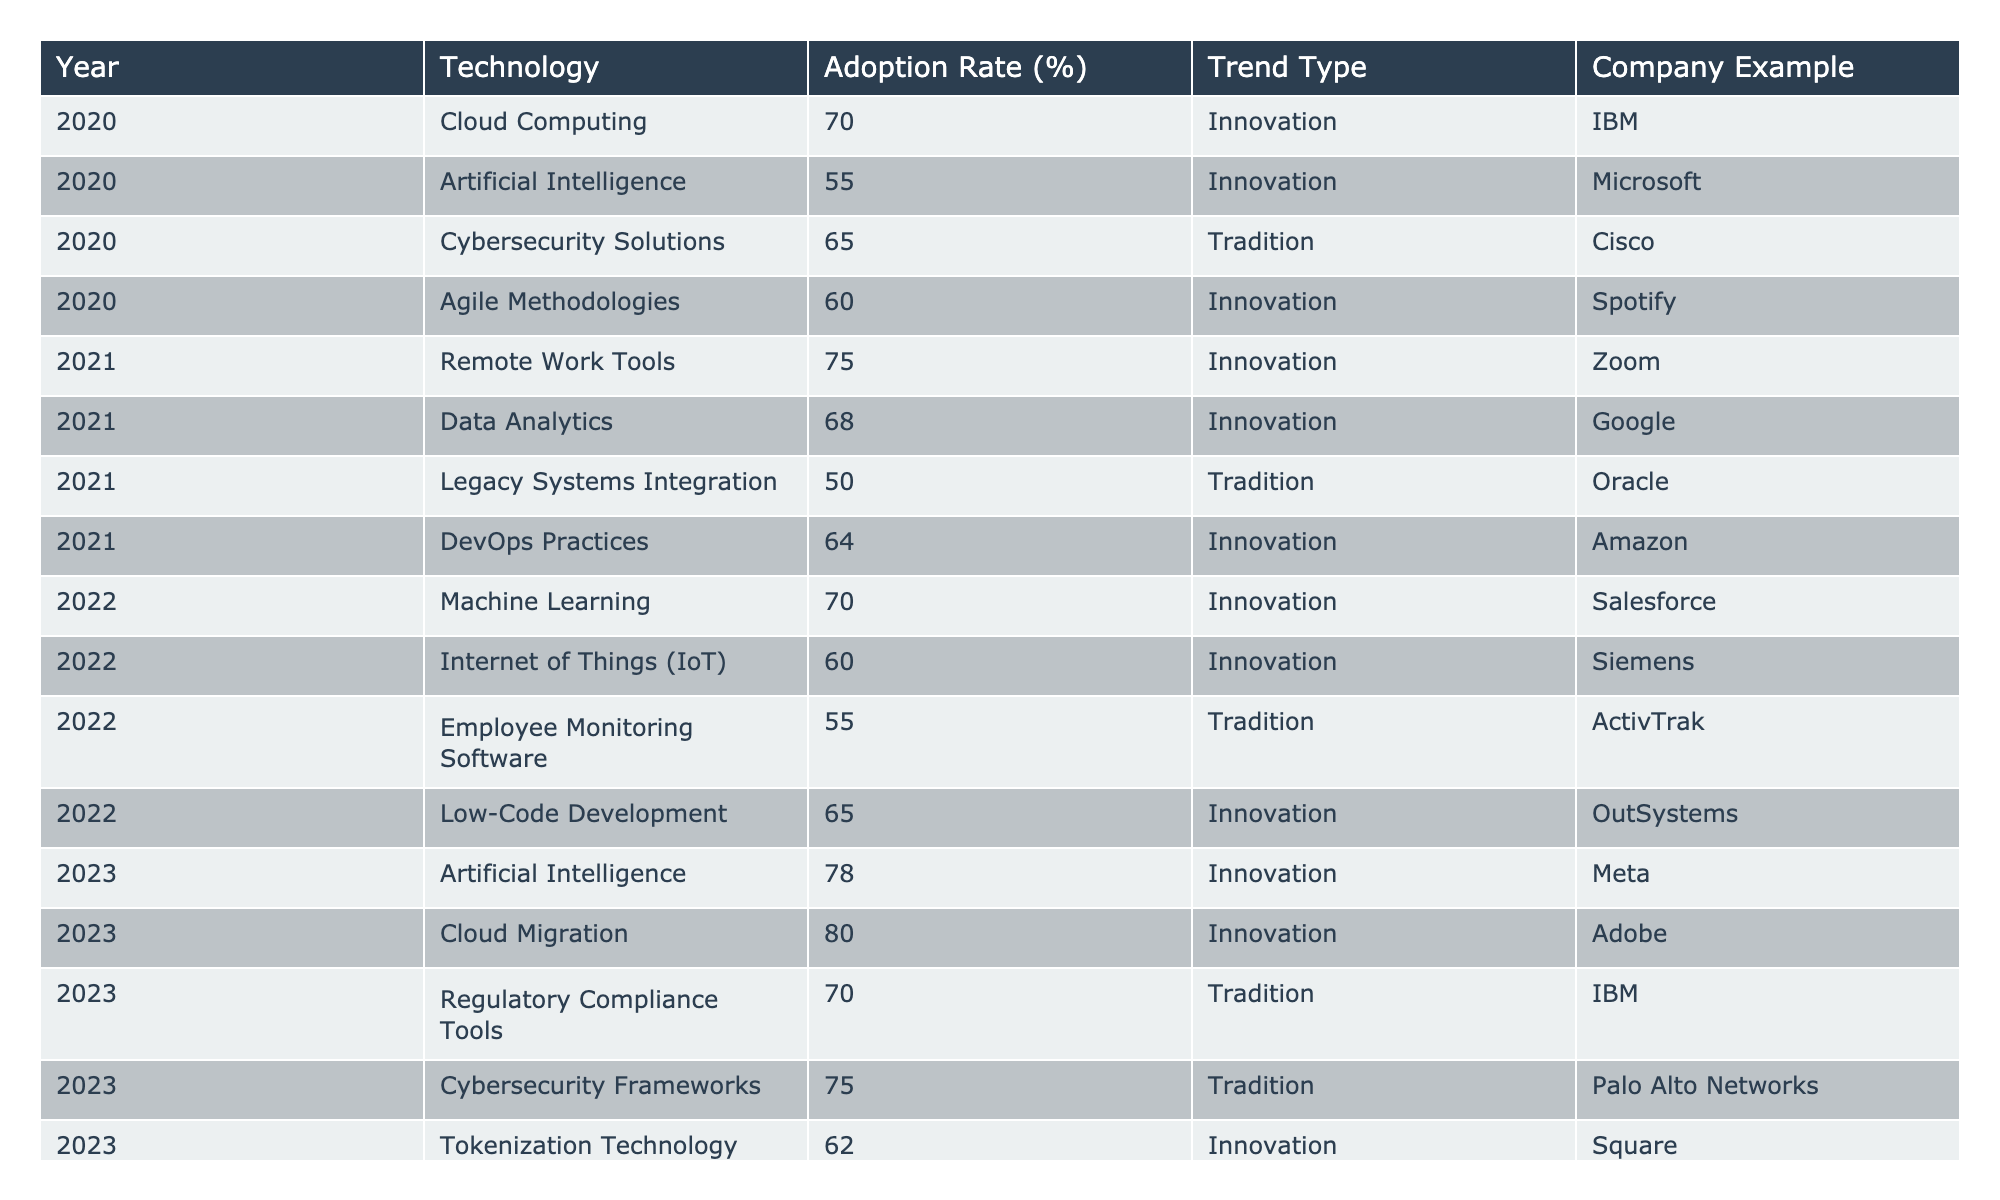What was the adoption rate of Cloud Computing in 2020? The table shows that the adoption rate for Cloud Computing in 2020 was 70%.
Answer: 70% Which year saw the highest adoption of Remote Work Tools? According to the table, Remote Work Tools had an adoption rate of 75% in 2021, which was the highest recorded in the table.
Answer: 2021 Is the adoption rate for Cybersecurity Solutions higher in 2020 or 2023? The table lists Cybersecurity Solutions with an adoption rate of 65% in 2020 and 75% in 2023, indicating it was higher in 2023.
Answer: 2023 What was the average adoption rate for Innovation technologies in 2022? The adoption rates for Innovation technologies in 2022 were Machine Learning (70%), Internet of Things (IoT) (60%), and Low-Code Development (65%). The average is (70 + 60 + 65) / 3 = 65.
Answer: 65% Which technology had the lowest adoption rate in 2021? The table indicates that the technology with the lowest adoption rate in 2021 was Legacy Systems Integration with a rate of 50%.
Answer: 50% Are there any trends where the adoption rates increased from 2020 to 2023? Yes, the table shows that Artificial Intelligence increased from 55% in 2020 to 78% in 2023. Another example is Cloud Computing, which went from 70% in 2020 to 80% in 2023.
Answer: Yes Which company's technology saw a decline in the adoption rate from 2020 to 2023? The table highlights that Employee Monitoring Software, offered by ActivTrak, had a decrease from 55% in 2022 to no entry in 2023.
Answer: ActivTrak What is the difference in adoption rates between the highest and lowest Innovation technologies in 2023? The highest Innovation technology in 2023 was Cloud Migration at 80%, while the lowest was Tokenization Technology at 62%. The difference is 80 - 62 = 18.
Answer: 18 Which company had an example of a traditional technology with an adoption rate of 70% in 2023? The table indicates that IBM had Regulatory Compliance Tools as a traditional technology with a 70% adoption rate in 2023.
Answer: IBM 